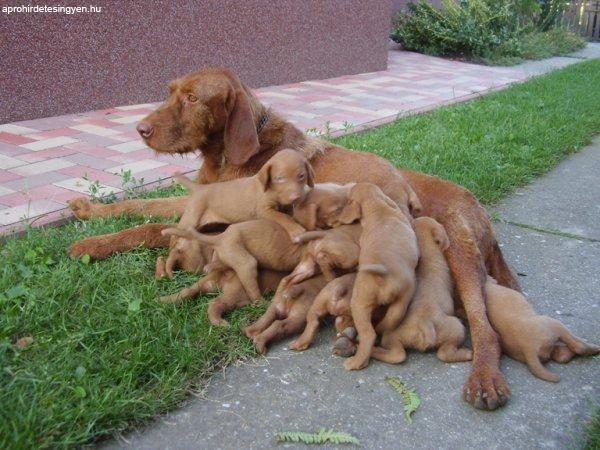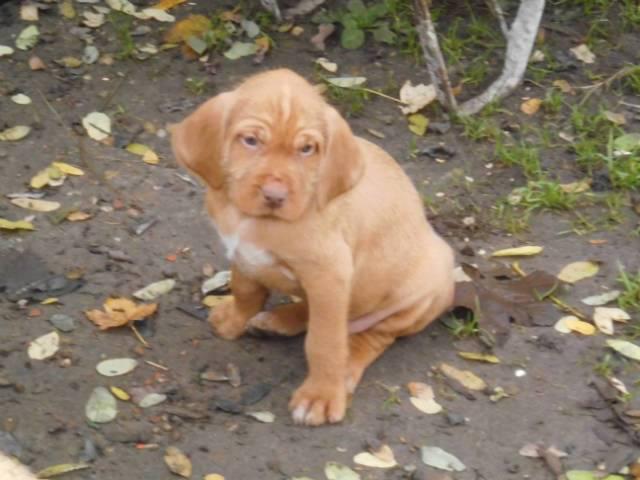The first image is the image on the left, the second image is the image on the right. Analyze the images presented: Is the assertion "At least 4 puppies are laying on the ground next to their mama." valid? Answer yes or no. Yes. The first image is the image on the left, the second image is the image on the right. Given the left and right images, does the statement "The right image features one dog in a sitting pose with body turned left and head turned straight, and the left image features a reclining mother dog with at least four puppies in front of her." hold true? Answer yes or no. Yes. 